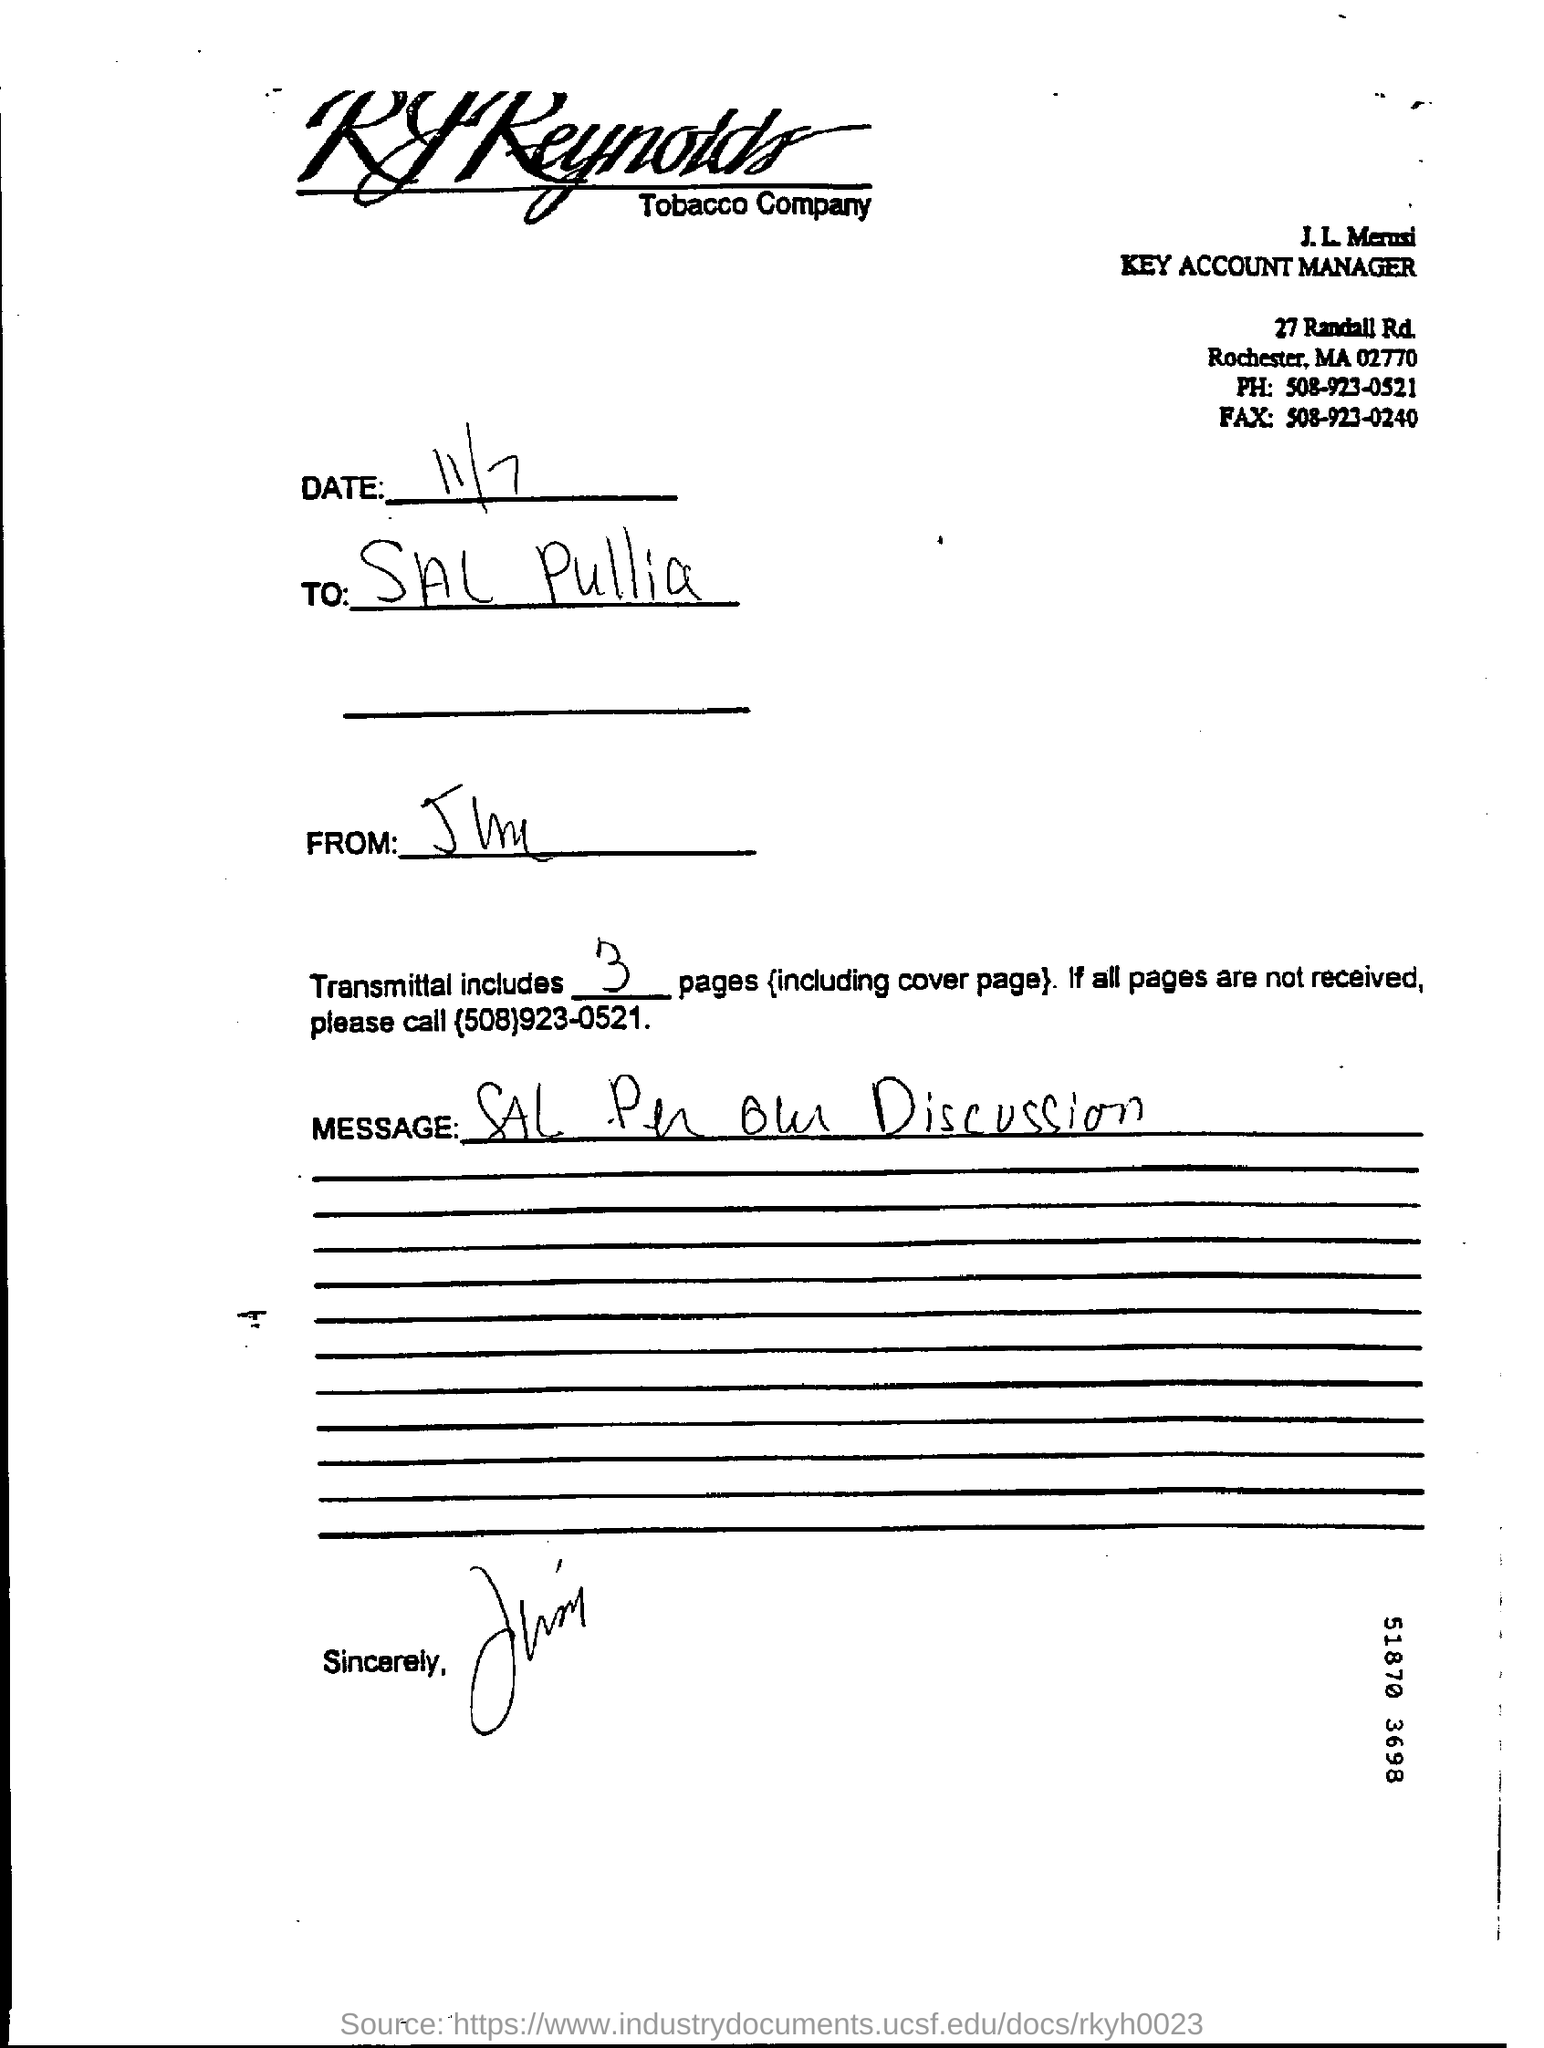What is the phone number of the j.l. merusi?
Your answer should be very brief. 508-923-0521. What is the fax number of the j.l. merusi?
Ensure brevity in your answer.  508-923-0240. What is the date in the document?
Give a very brief answer. 11/7. 